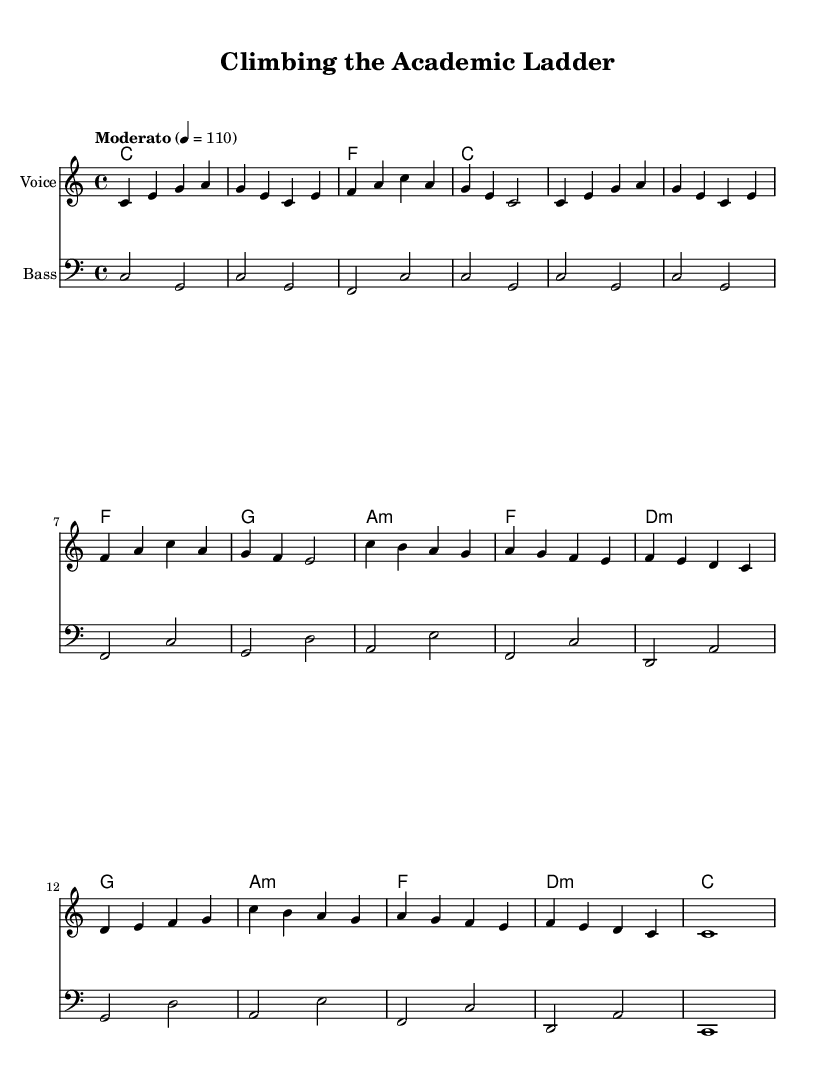What is the key signature of this music? The key signature is indicated at the beginning of the sheet music and shows C major, which has no sharps or flats.
Answer: C major What is the time signature of this music? The time signature appears early in the score, written as a fraction, and it shows 4/4, meaning there are four beats per measure and the quarter note gets one beat.
Answer: 4/4 What is the tempo marking of the piece? The tempo is specified in the score, noted as "Moderato" with a metronome marking of 110, indicating a moderately paced tempo.
Answer: Moderato 4 = 110 How many measures are there in the melody? By counting the distinct sections or bars in the melody, one can find that there are 16 measures total.
Answer: 16 What type of harmony is used in this piece? The harmony section shows a mix of major and minor chords, and it specifically includes a use of triads, typical for soul music that often includes I-IV-V progressions.
Answer: Triads What is the bass clef's starting note? The bass clef starts with a "C" in the lower staff, established from the relative pitch marked at the beginning of this section.
Answer: C Is this composition structured in verse and chorus format? Analyzing the repetition and layout of the sections, the piece is structured in a format that mimics a verse and chorus pattern as common in soul music.
Answer: Yes 